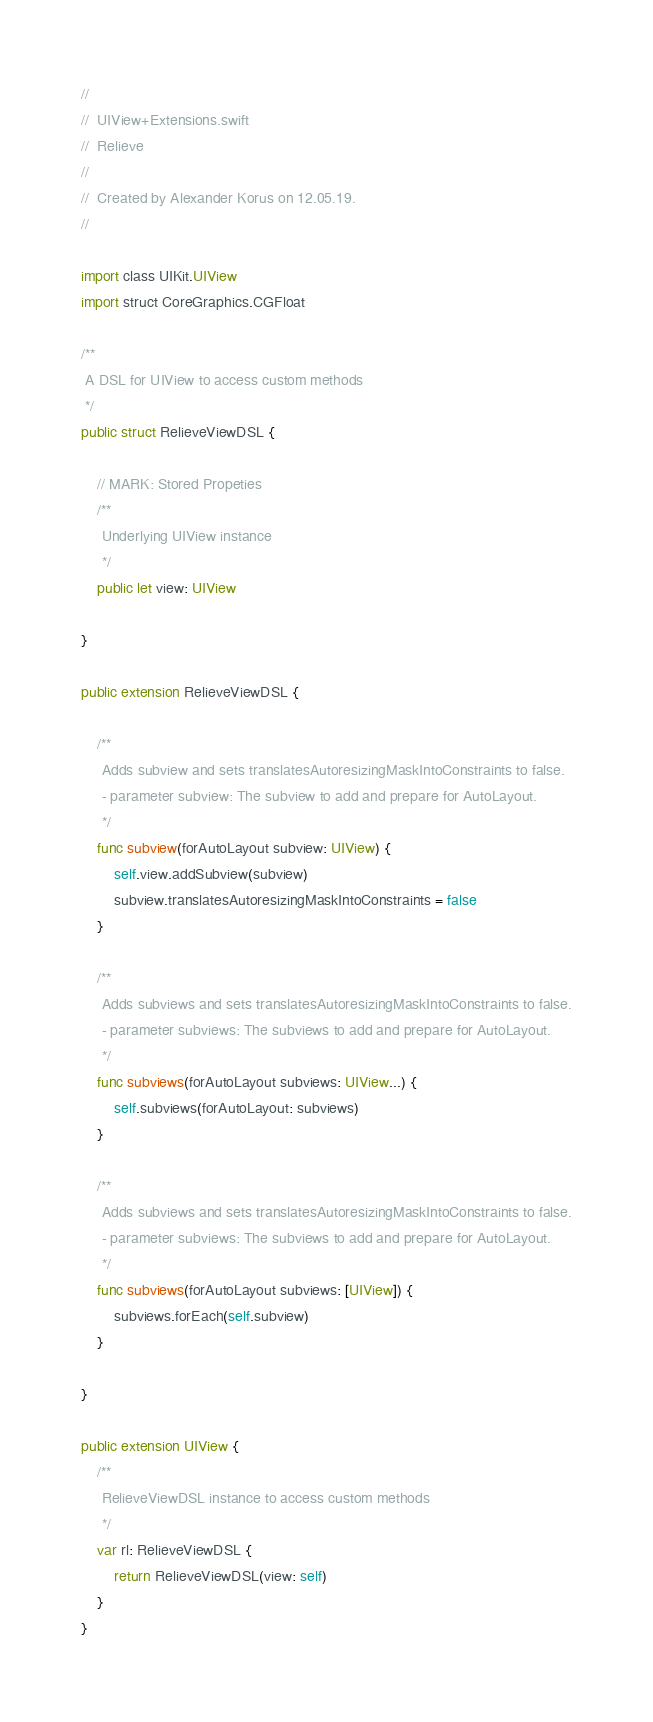Convert code to text. <code><loc_0><loc_0><loc_500><loc_500><_Swift_>//
//  UIView+Extensions.swift
//  Relieve
//
//  Created by Alexander Korus on 12.05.19.
//

import class UIKit.UIView
import struct CoreGraphics.CGFloat

/**
 A DSL for UIView to access custom methods
 */
public struct RelieveViewDSL {
    
    // MARK: Stored Propeties
    /**
     Underlying UIView instance
     */
    public let view: UIView
    
}

public extension RelieveViewDSL {
    
    /**
     Adds subview and sets translatesAutoresizingMaskIntoConstraints to false.
     - parameter subview: The subview to add and prepare for AutoLayout.
     */
    func subview(forAutoLayout subview: UIView) {
        self.view.addSubview(subview)
        subview.translatesAutoresizingMaskIntoConstraints = false
    }
    
    /**
     Adds subviews and sets translatesAutoresizingMaskIntoConstraints to false.
     - parameter subviews: The subviews to add and prepare for AutoLayout.
     */
    func subviews(forAutoLayout subviews: UIView...) {
        self.subviews(forAutoLayout: subviews)
    }
    
    /**
     Adds subviews and sets translatesAutoresizingMaskIntoConstraints to false.
     - parameter subviews: The subviews to add and prepare for AutoLayout.
     */
    func subviews(forAutoLayout subviews: [UIView]) {
        subviews.forEach(self.subview)
    }
    
}

public extension UIView {
    /**
     RelieveViewDSL instance to access custom methods
     */
    var rl: RelieveViewDSL {
        return RelieveViewDSL(view: self)
    }
}
</code> 